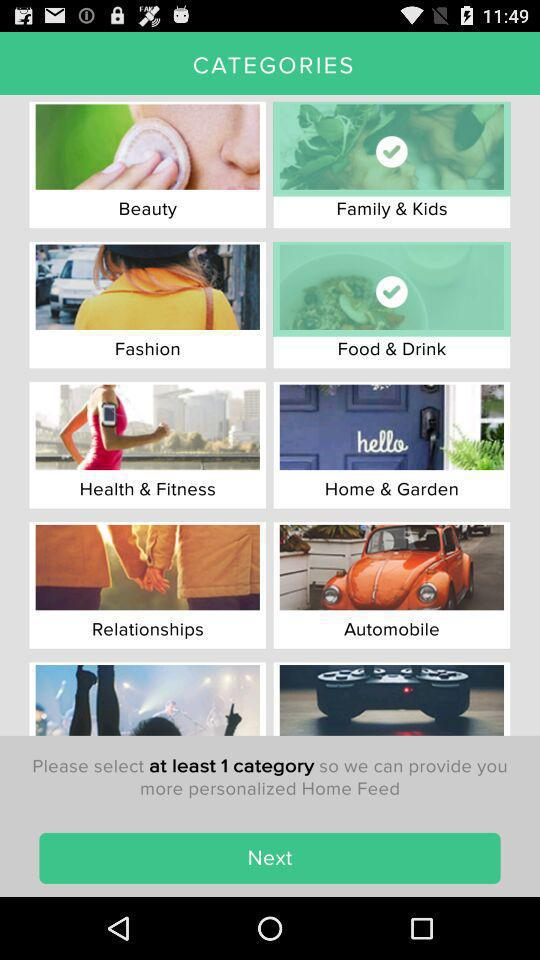How many categories are to be selected? You need to select at least 1 category. 